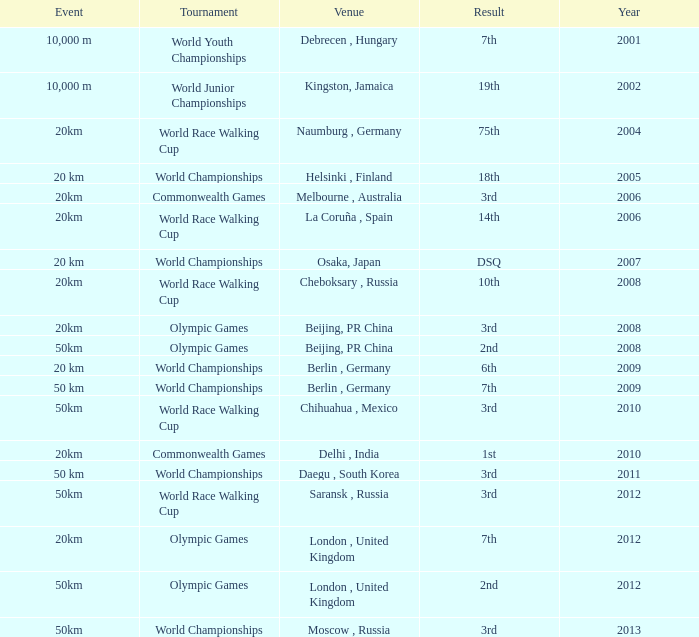What is the year of the tournament played at Melbourne, Australia? 2006.0. 